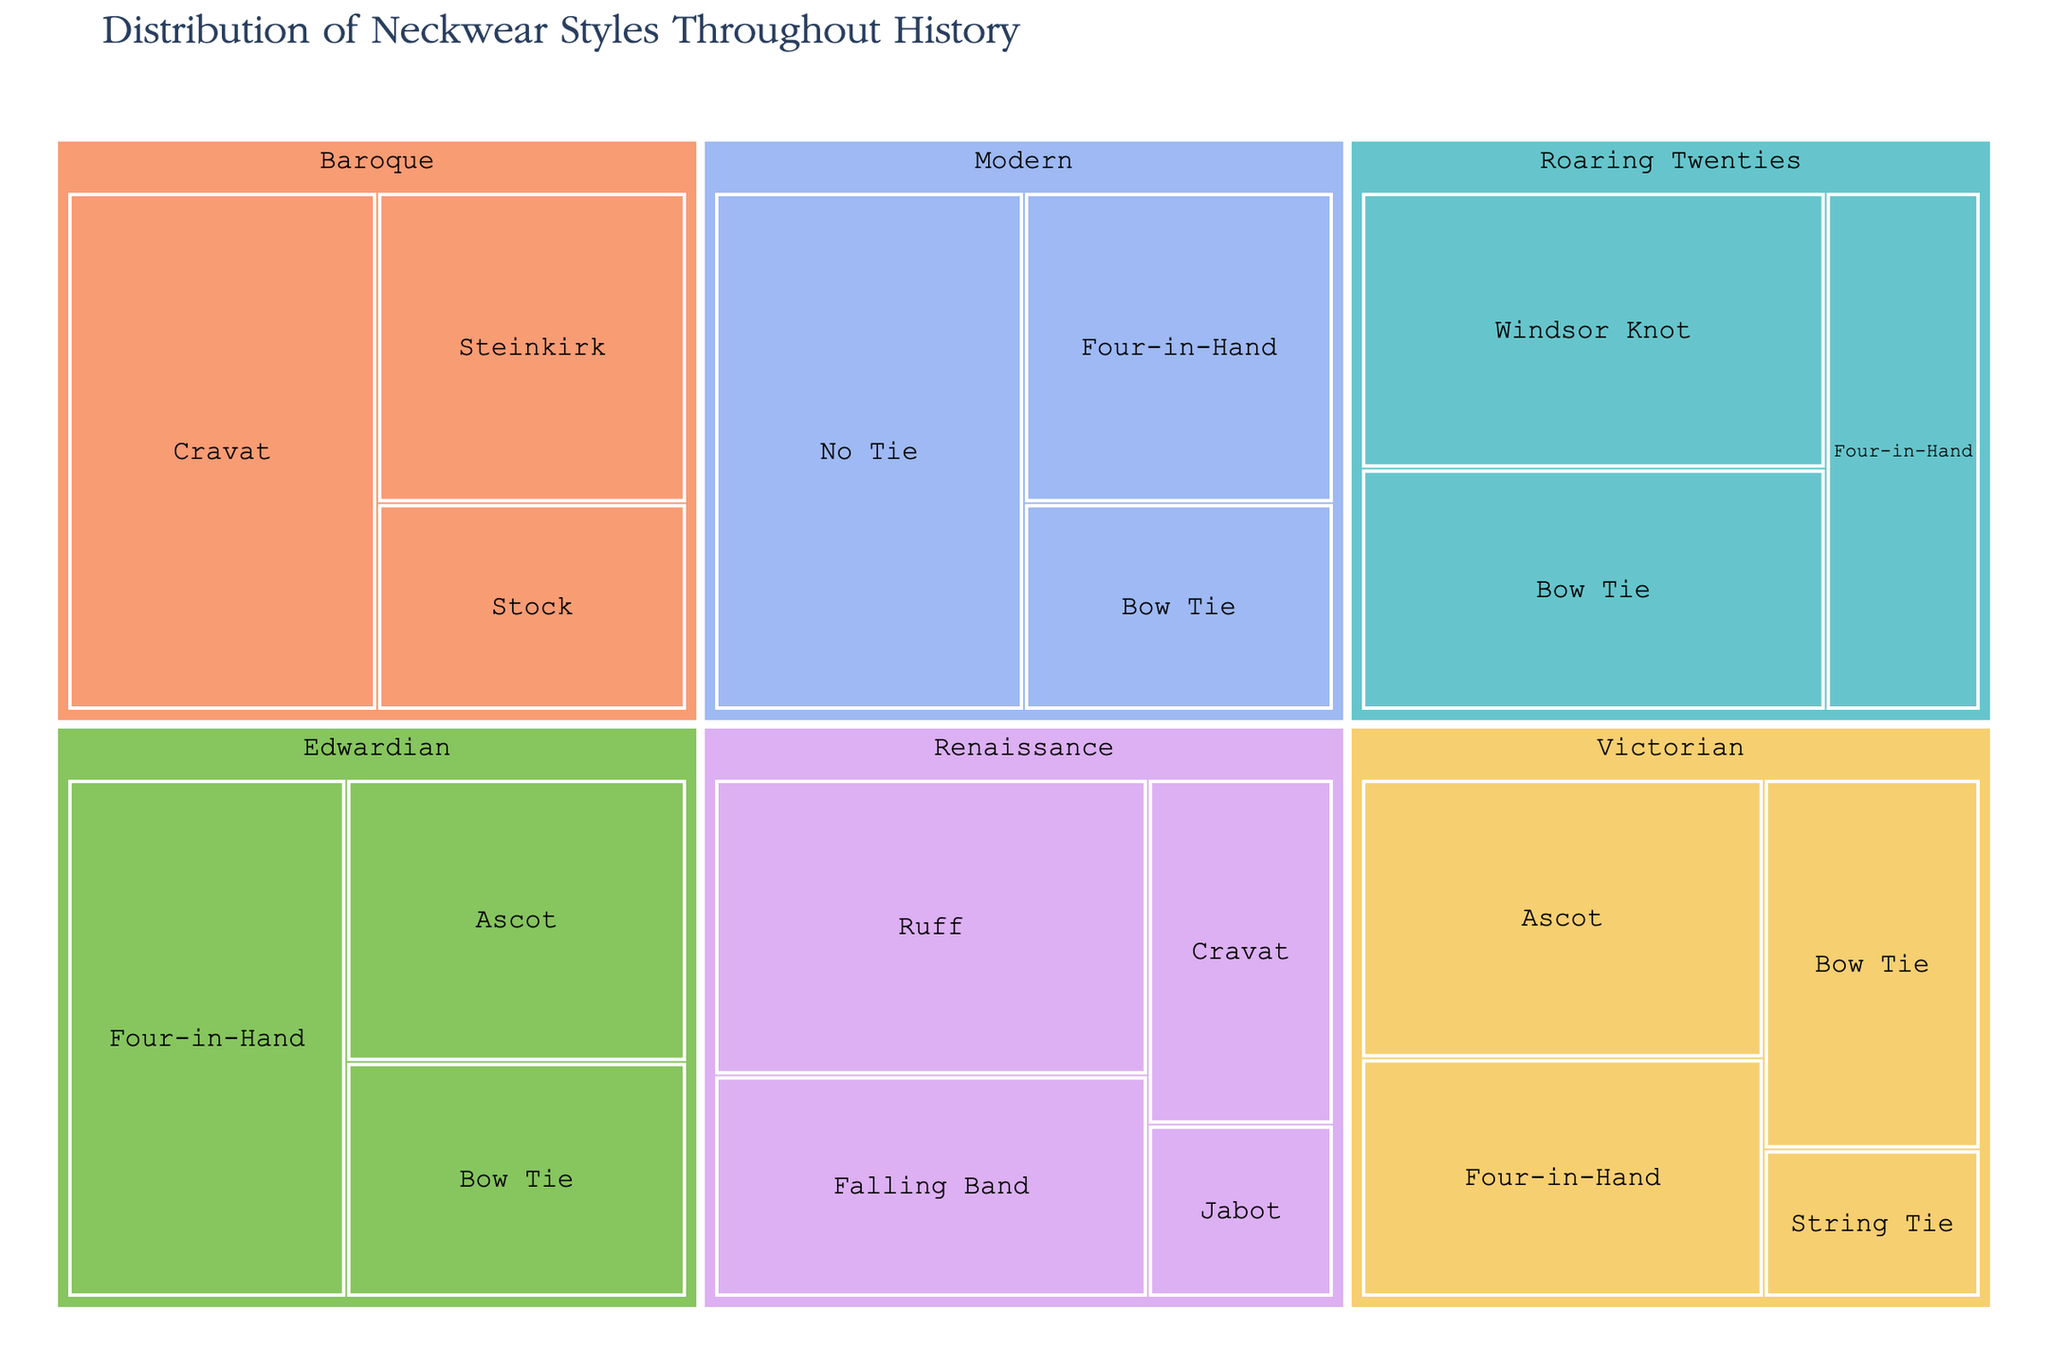What's the most popular neckwear style in the Renaissance period? Look at the sections labeled under the Renaissance period and identify the style with the highest percentage. Ruff is at 40%, the highest in this period.
Answer: Ruff Which period has the highest popularity for the cravat? Compare the size of the Cravat sections in Renaissance and Baroque periods. Baroque's Cravat has 50%, whereas Renaissance's Cravat has 20%.
Answer: Baroque What is the total popularity of bow ties across all periods? Add the percentages of bow ties from Victorian (25%), Edwardian (25%), Roaring Twenties (35%), and Modern (20%). The total is 25 + 25 + 35 + 20 = 105%.
Answer: 105% Which neckwear style is unique to the Roaring Twenties period? Identify the style that is only found under the Roaring Twenties period. Windsor Knot appears solely in this period.
Answer: Windsor Knot What's the difference in popularity between the most popular and the least popular style in the Renaissance period? Find the percentages for the most popular (Ruff, 40%) and the least popular (Jabot, 10%) styles in the Renaissance period, then subtract the latter from the former: 40% - 10% = 30%.
Answer: 30% What's the least popular style in the Baroque period? Look at the Baroque period and find the style with the lowest percentage. The Stock style has the lowest popularity at 20%.
Answer: Stock Among the modern neckwear styles, which one is more popular: Four-in-Hand or Bow Tie? Compare the percentages for Four-in-Hand (30%) and Bow Tie (20%) under the Modern section. Four-in-Hand is more popular.
Answer: Four-in-Hand What is the combined popularity of all neckwear styles in the Edwardian period? Add up the percentages for all styles in the Edwardian period: Four-in-Hand (45%), Ascot (30%), and Bow Tie (25%). The sum is 45 + 30 + 25 = 100%.
Answer: 100% Which period features styles like the Steinkirk and Stock? Identify the period that includes the Steinkirk and the Stock. Both are found in the Baroque period.
Answer: Baroque How many unique neckwear styles are presented in the Victorian period? Count the distinct styles listed under the Victorian period: Ascot, Four-in-Hand, Bow Tie, String Tie. There are 4 unique styles.
Answer: 4 